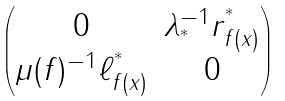<formula> <loc_0><loc_0><loc_500><loc_500>\begin{pmatrix} 0 & \lambda _ { ^ { * } } ^ { - 1 } r _ { f ( x ) } ^ { ^ { * } } \\ \mu ( f ) ^ { - 1 } \ell _ { f ( x ) } ^ { ^ { * } } & 0 \end{pmatrix}</formula> 